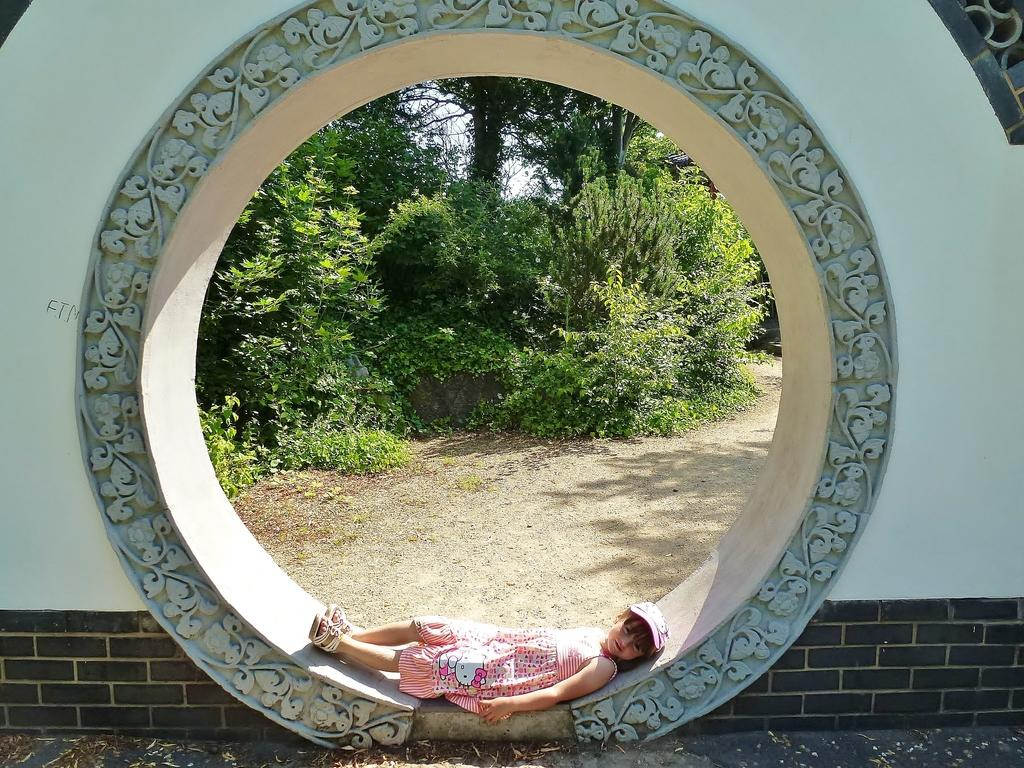Who is the main subject in the foreground of the image? There is a girl in the foreground of the image. What is the girl wearing? The girl is wearing a pink dress. Where is the girl positioned in the image? The girl is lying on a circular arch wall. What can be seen in the background of the image? There are trees and the ground visible in the background of the image. What type of pets can be seen playing with the girl in the image? There are no pets visible in the image; the girl is lying on a circular arch wall with no animals present. 